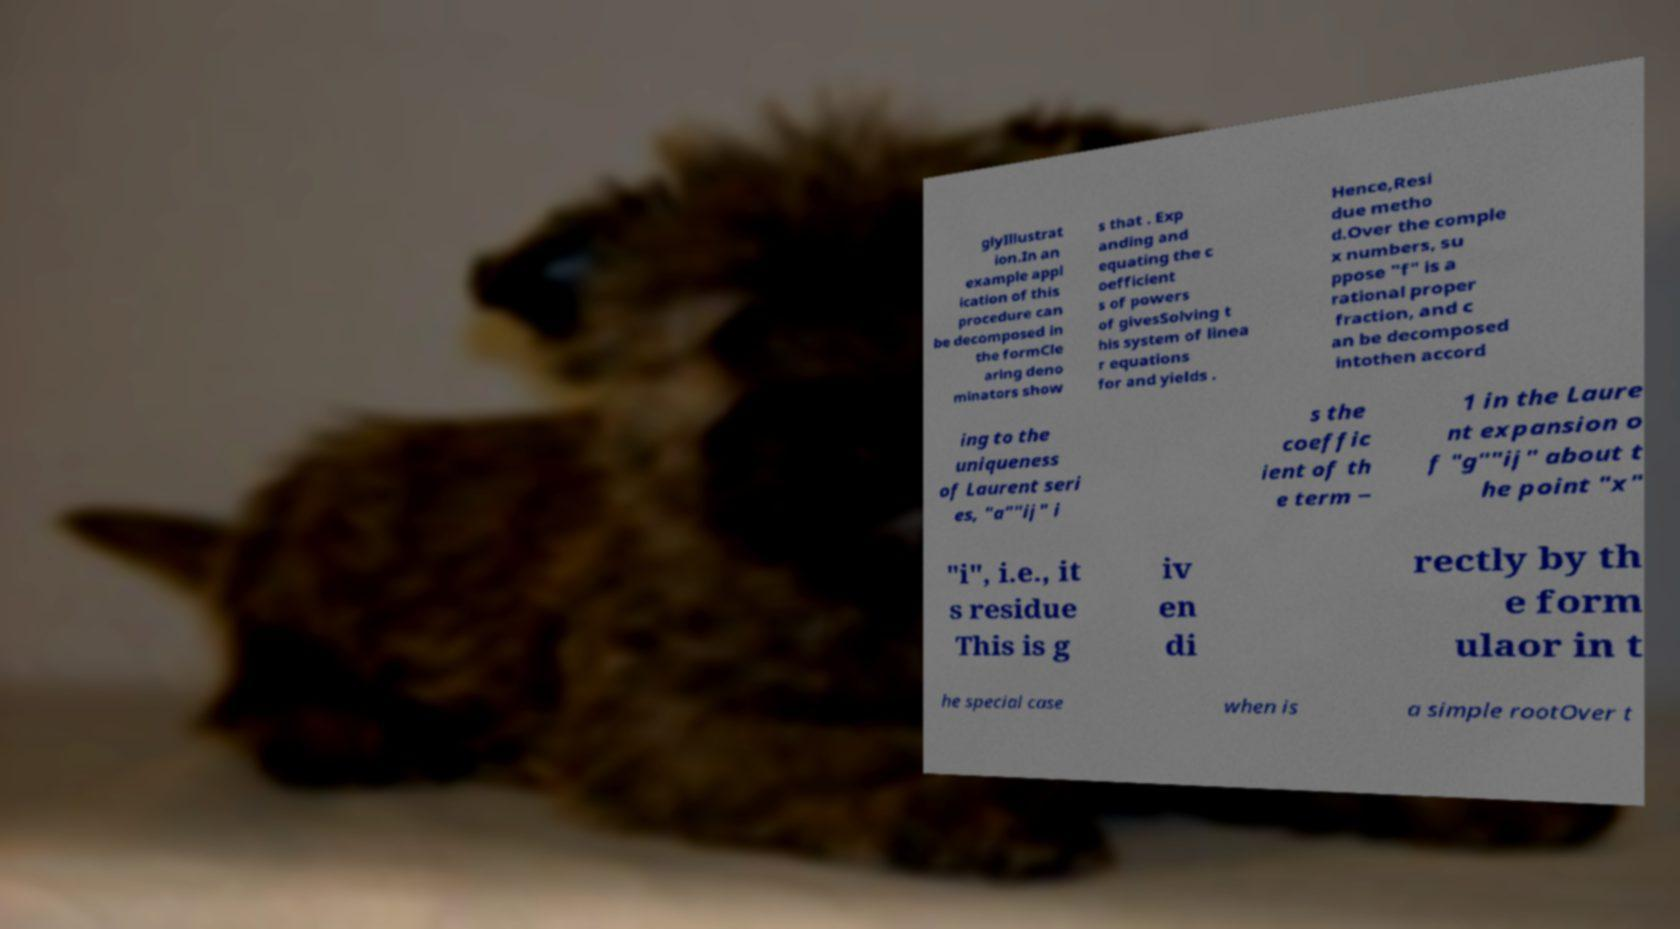Could you extract and type out the text from this image? glyIllustrat ion.In an example appl ication of this procedure can be decomposed in the formCle aring deno minators show s that . Exp anding and equating the c oefficient s of powers of givesSolving t his system of linea r equations for and yields . Hence,Resi due metho d.Over the comple x numbers, su ppose "f" is a rational proper fraction, and c an be decomposed intothen accord ing to the uniqueness of Laurent seri es, "a""ij" i s the coeffic ient of th e term − 1 in the Laure nt expansion o f "g""ij" about t he point "x" "i", i.e., it s residue This is g iv en di rectly by th e form ulaor in t he special case when is a simple rootOver t 